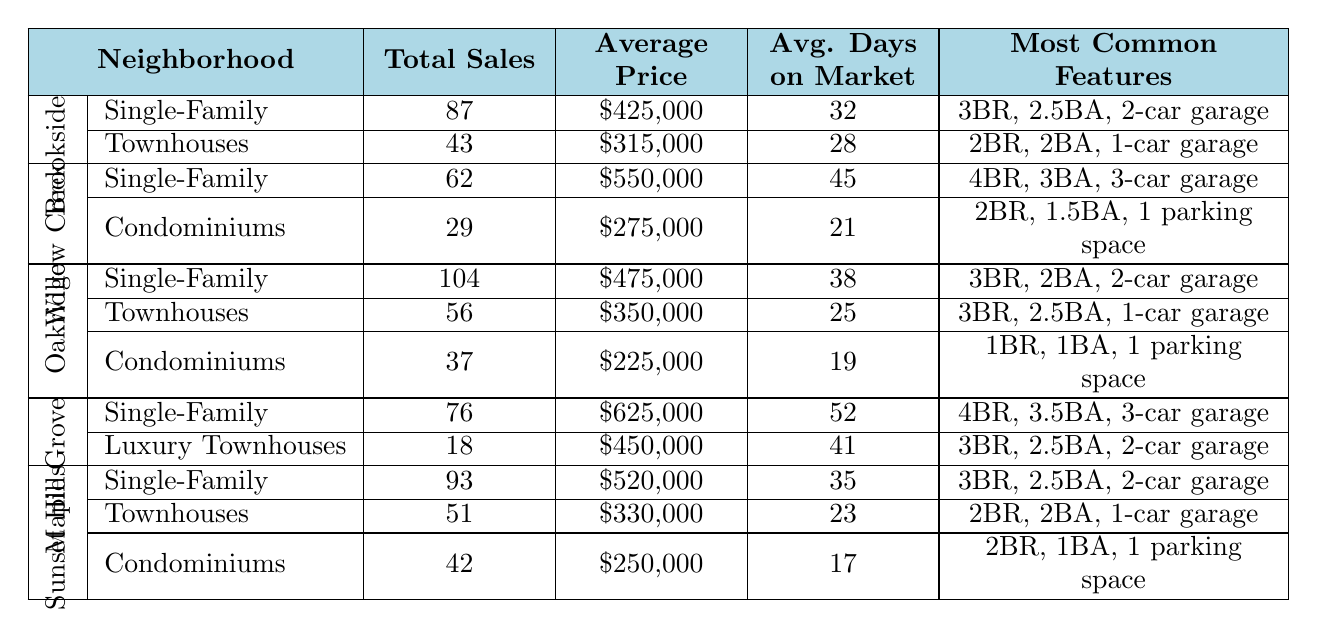What is the total number of single-family homes sold in Sunset Hills? According to the data, Sunset Hills has sold 93 single-family homes.
Answer: 93 Which neighborhood has the highest average price for single-family homes? Comparing the average prices of single-family homes: Brookside ($425,000), Willow Creek ($550,000), Oakridge ($475,000), Maple Grove ($625,000), and Sunset Hills ($520,000), Maple Grove has the highest average price at $625,000.
Answer: Maple Grove How many total condominium sales occurred in Oakridge Community? The data indicates that Oakridge Community had 37 condominium sales.
Answer: 37 What is the average price of townhouses in Willow Creek? The average price for townhouses in Willow Creek is $275,000, as stated in the neighborhood's data.
Answer: $275,000 In which neighborhood are the most common features for single-family homes "4 bedrooms, 3.5 bathrooms, 3-car garage"? These features correspond to the single-family homes in Maple Grove, making it the neighborhood in question.
Answer: Maple Grove What is the total number of property sales across all types in Brookside Estates? For Brookside Estates, single-family homes have 87 sales and townhouses have 43 sales, totaling 130 sales (87 + 43).
Answer: 130 What is the average number of days on market for townhouses in Sunset Hills and Brookside Estates? The average days on market for townhouses in Sunset Hills is 23 and for Brookside Estates is 28. Combining these: (23 + 28) / 2 = 25.5 average days on market.
Answer: 25.5 Is the average price of condominiums in Sunset Hills higher or lower than in Oakridge Community? The average price of condominiums in Sunset Hills is $250,000, while in Oakridge Community, it is $225,000. Thus, Sunset Hills' condominiums are higher in price.
Answer: Higher What is the average price difference between single-family homes in Willow Creek and Maple Grove? The average price for single-family homes in Willow Creek is $550,000, while in Maple Grove it is $625,000. The difference is $625,000 - $550,000 = $75,000.
Answer: $75,000 Which neighborhood has the lowest average days on market for any property type? Evaluating the data, Oakridge Community has a condominium type with the lowest average days on market at 19 days.
Answer: Oakridge Community 